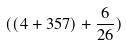<formula> <loc_0><loc_0><loc_500><loc_500>( ( 4 + 3 5 7 ) + \frac { 6 } { 2 6 } )</formula> 